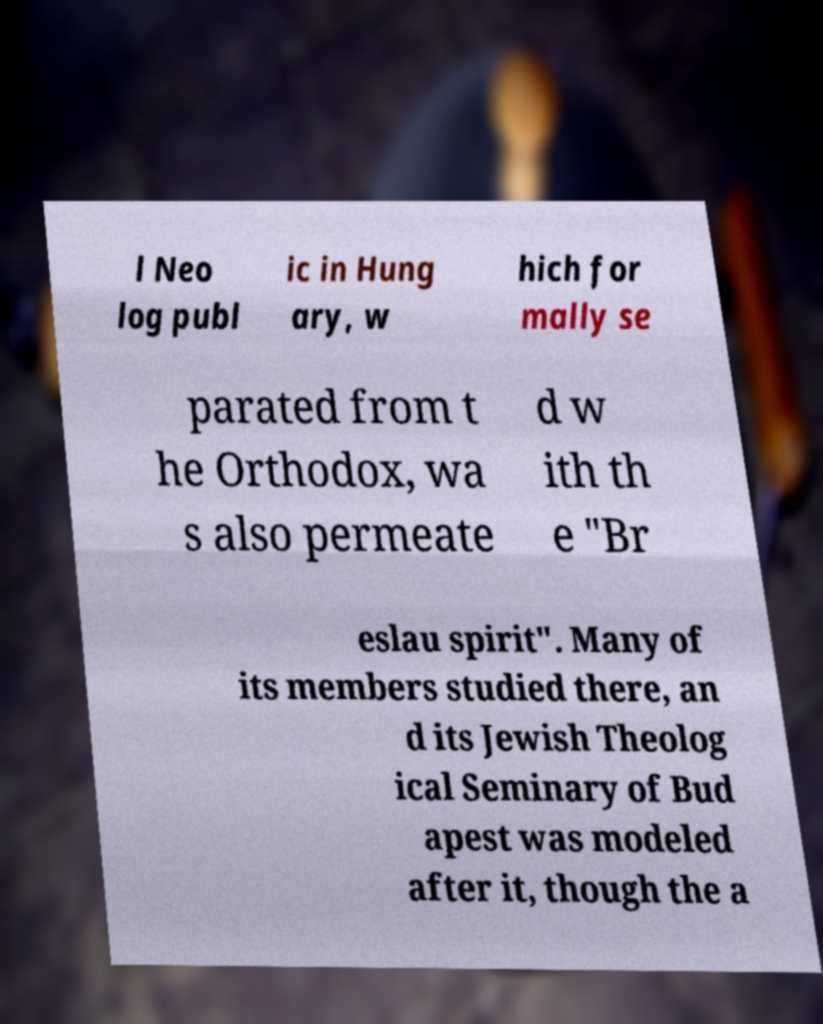Can you read and provide the text displayed in the image?This photo seems to have some interesting text. Can you extract and type it out for me? l Neo log publ ic in Hung ary, w hich for mally se parated from t he Orthodox, wa s also permeate d w ith th e "Br eslau spirit". Many of its members studied there, an d its Jewish Theolog ical Seminary of Bud apest was modeled after it, though the a 